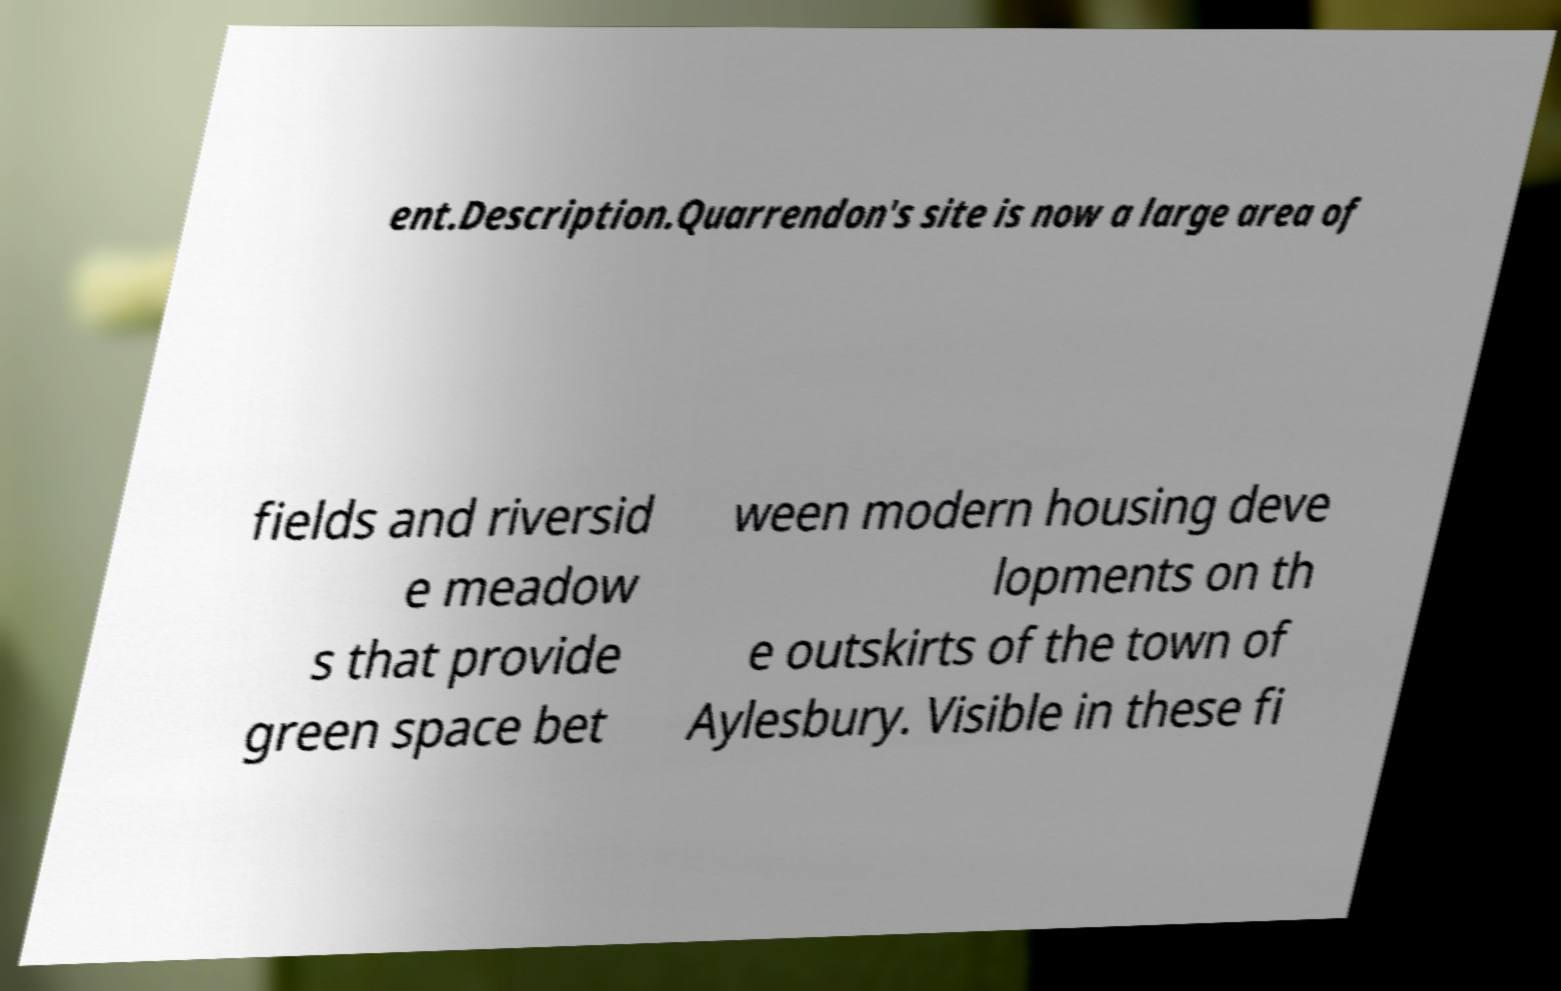Can you accurately transcribe the text from the provided image for me? ent.Description.Quarrendon's site is now a large area of fields and riversid e meadow s that provide green space bet ween modern housing deve lopments on th e outskirts of the town of Aylesbury. Visible in these fi 